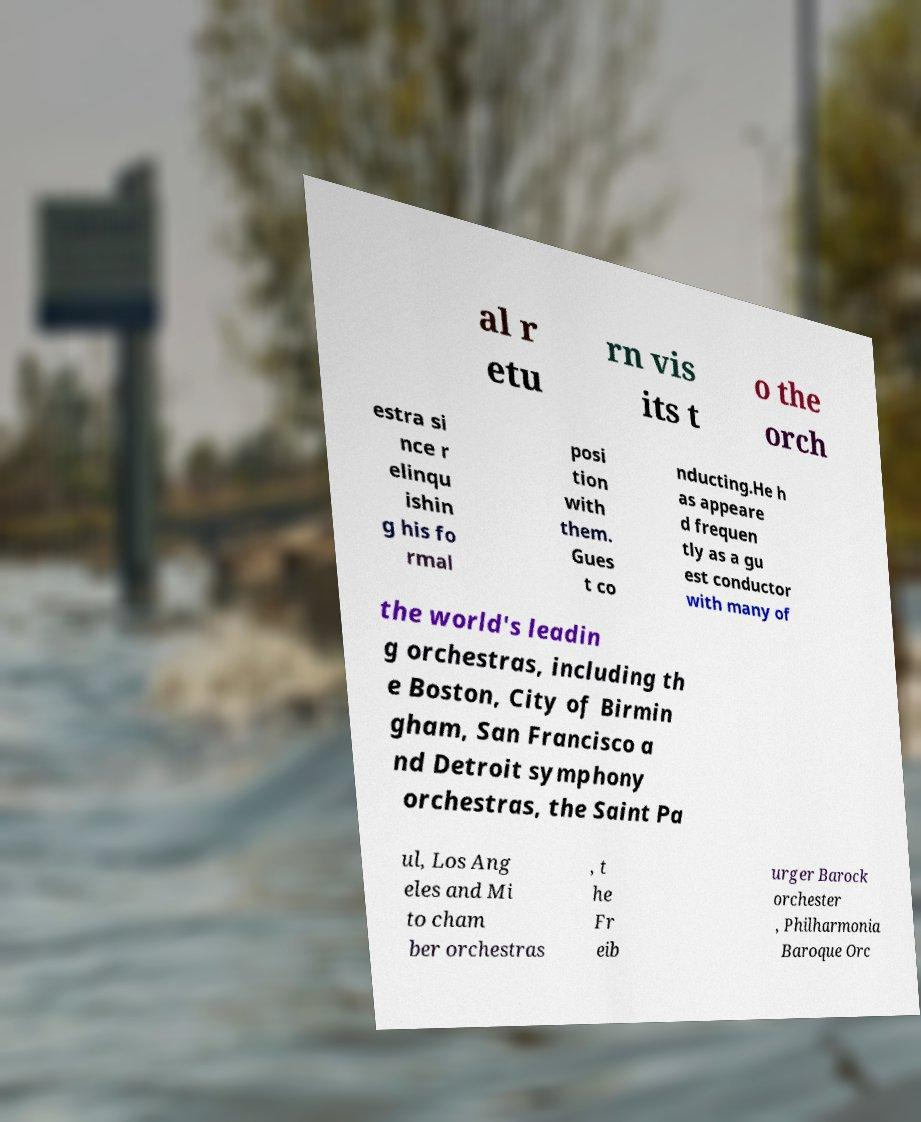Could you extract and type out the text from this image? al r etu rn vis its t o the orch estra si nce r elinqu ishin g his fo rmal posi tion with them. Gues t co nducting.He h as appeare d frequen tly as a gu est conductor with many of the world's leadin g orchestras, including th e Boston, City of Birmin gham, San Francisco a nd Detroit symphony orchestras, the Saint Pa ul, Los Ang eles and Mi to cham ber orchestras , t he Fr eib urger Barock orchester , Philharmonia Baroque Orc 